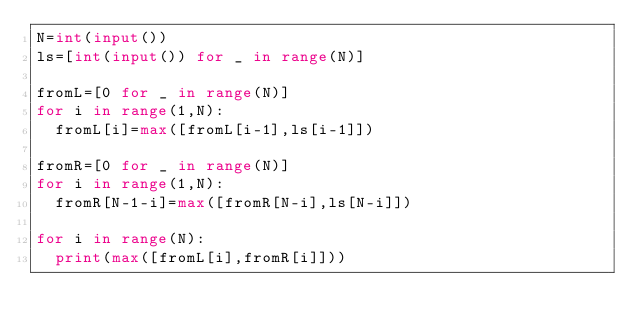<code> <loc_0><loc_0><loc_500><loc_500><_Python_>N=int(input())
ls=[int(input()) for _ in range(N)]

fromL=[0 for _ in range(N)]
for i in range(1,N):
  fromL[i]=max([fromL[i-1],ls[i-1]])

fromR=[0 for _ in range(N)]
for i in range(1,N):
  fromR[N-1-i]=max([fromR[N-i],ls[N-i]])

for i in range(N):
  print(max([fromL[i],fromR[i]]))</code> 